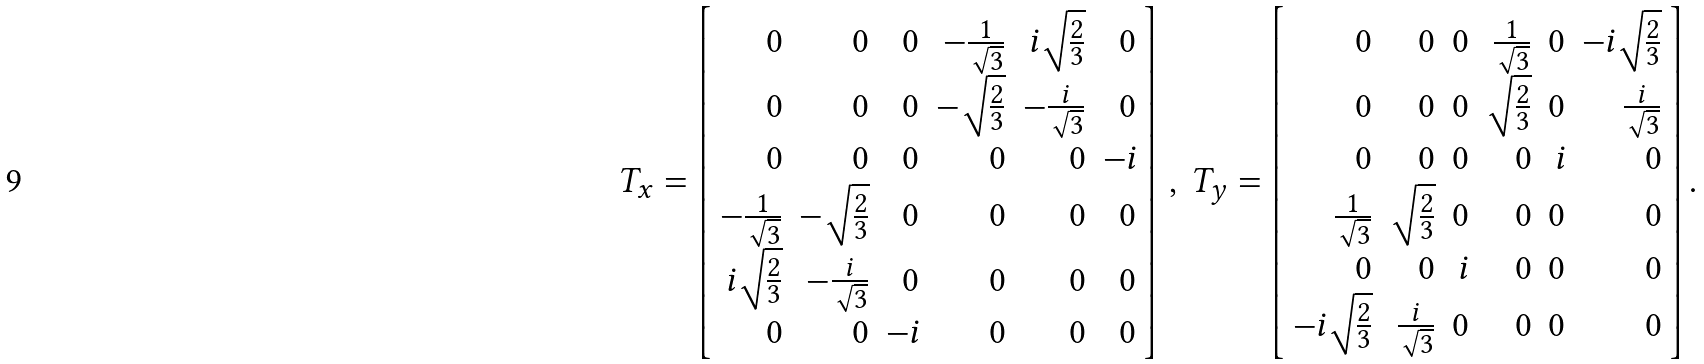Convert formula to latex. <formula><loc_0><loc_0><loc_500><loc_500>T _ { x } = \left [ \begin{array} { r r r r r r } 0 & 0 & 0 & - \frac { 1 } { \sqrt { 3 } } & i \sqrt { \frac { 2 } { 3 } } & 0 \\ 0 & 0 & 0 & - \sqrt { \frac { 2 } { 3 } } & - \frac { i } { \sqrt { 3 } } & 0 \\ 0 & 0 & 0 & 0 & 0 & - i \\ - \frac { 1 } { \sqrt { 3 } } & - \sqrt { \frac { 2 } { 3 } } & 0 & 0 & 0 & 0 \\ i \sqrt { \frac { 2 } { 3 } } & - \frac { i } { \sqrt { 3 } } & 0 & 0 & 0 & 0 \\ 0 & 0 & - i & 0 & 0 & 0 \end{array} \right ] \, , \, T _ { y } = \left [ \begin{array} { r r r r r r } 0 & 0 & 0 & \frac { 1 } { \sqrt { 3 } } & 0 & - i \sqrt { \frac { 2 } { 3 } } \\ 0 & 0 & 0 & \sqrt { \frac { 2 } { 3 } } & 0 & \frac { i } { \sqrt { 3 } } \\ 0 & 0 & 0 & 0 & i & 0 \\ \frac { 1 } { \sqrt { 3 } } & \sqrt { \frac { 2 } { 3 } } & 0 & 0 & 0 & 0 \\ 0 & 0 & i & 0 & 0 & 0 \\ - i \sqrt { \frac { 2 } { 3 } } & \frac { i } { \sqrt { 3 } } & 0 & 0 & 0 & 0 \end{array} \right ] .</formula> 